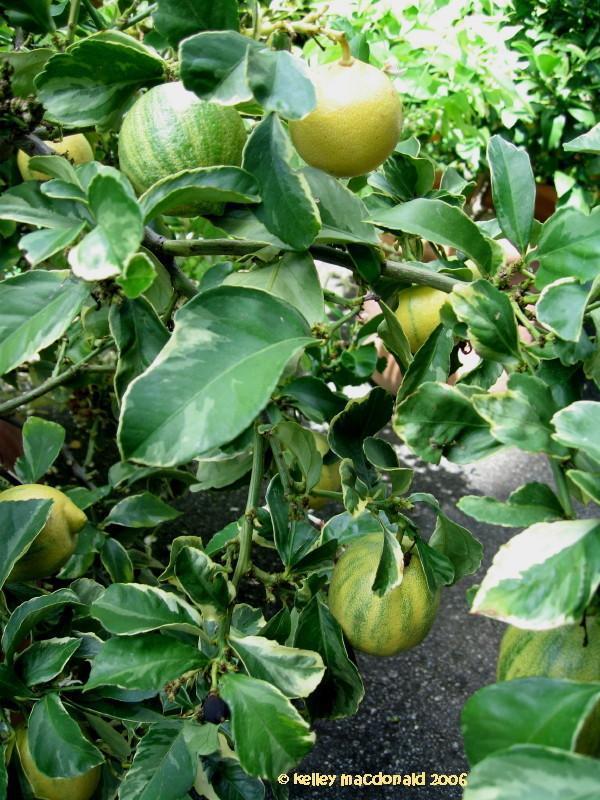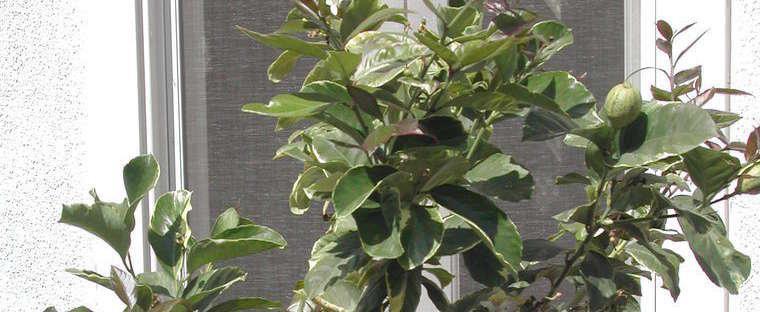The first image is the image on the left, the second image is the image on the right. Assess this claim about the two images: "There are lemon trees in both images.". Correct or not? Answer yes or no. Yes. 